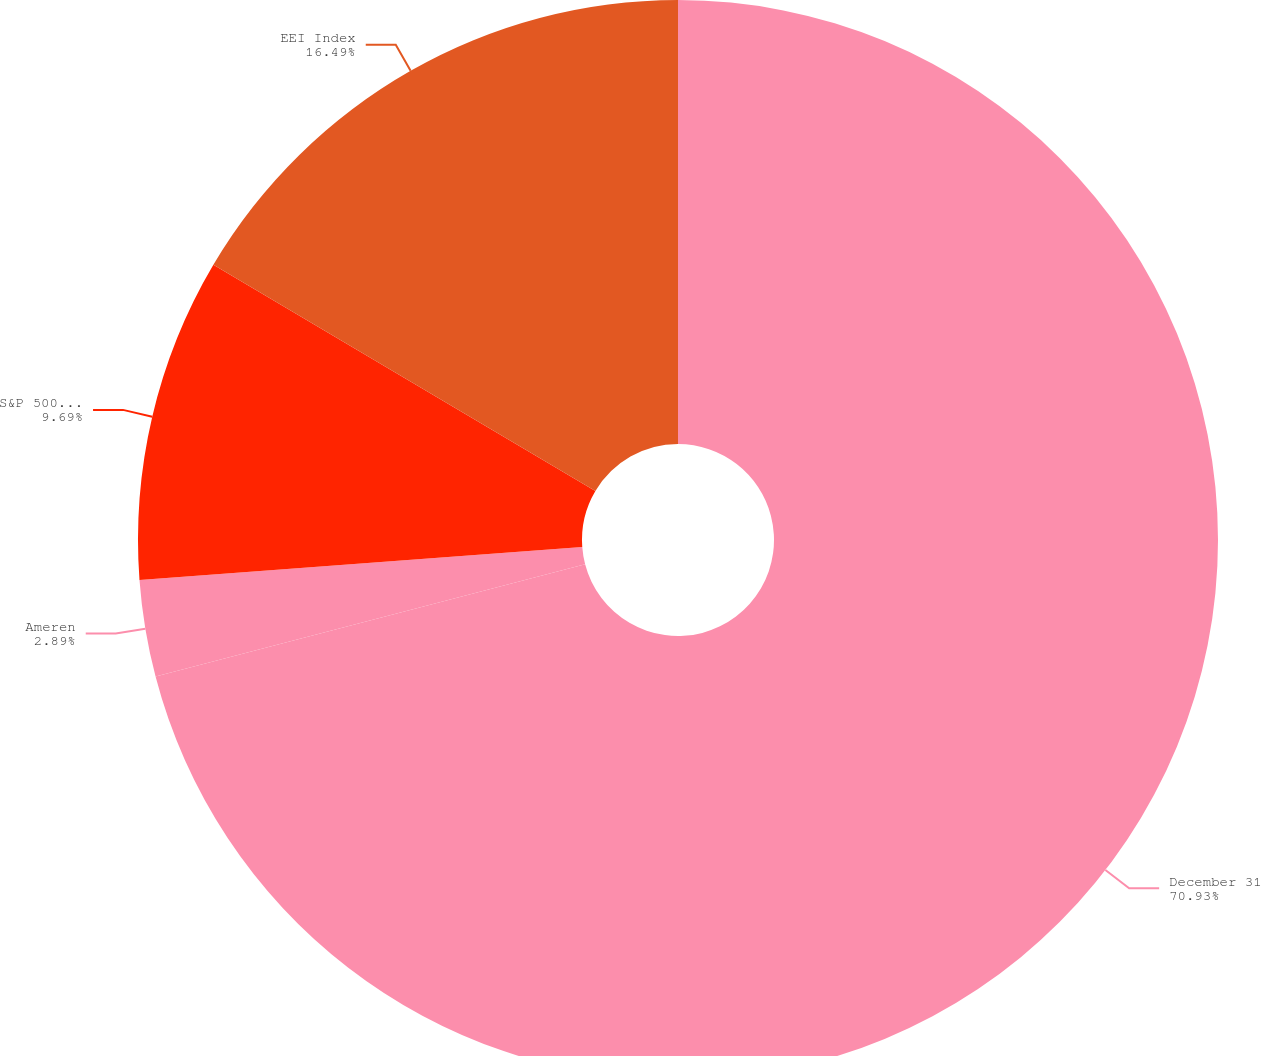<chart> <loc_0><loc_0><loc_500><loc_500><pie_chart><fcel>December 31<fcel>Ameren<fcel>S&P 500 Index<fcel>EEI Index<nl><fcel>70.93%<fcel>2.89%<fcel>9.69%<fcel>16.49%<nl></chart> 